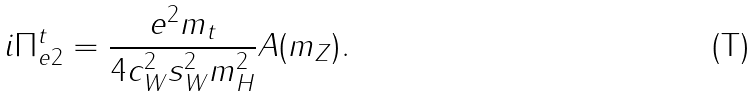<formula> <loc_0><loc_0><loc_500><loc_500>i \Pi ^ { t } _ { e 2 } = \frac { e ^ { 2 } m _ { t } } { 4 c _ { W } ^ { 2 } s _ { W } ^ { 2 } m _ { H } ^ { 2 } } A ( m _ { Z } ) .</formula> 